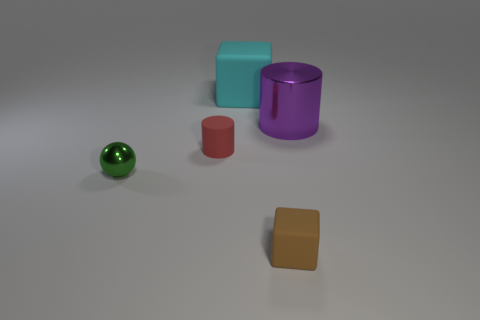What is the shape of the tiny green metallic thing?
Provide a short and direct response. Sphere. There is a thing that is in front of the metal thing that is left of the big purple shiny thing; what is its color?
Your answer should be very brief. Brown. The shiny thing that is the same size as the brown block is what color?
Provide a succinct answer. Green. Are any brown matte blocks visible?
Give a very brief answer. Yes. The metal thing that is in front of the purple metal cylinder has what shape?
Offer a very short reply. Sphere. What number of shiny things are both behind the small rubber cylinder and in front of the large shiny cylinder?
Give a very brief answer. 0. What number of other objects are there of the same size as the sphere?
Provide a succinct answer. 2. There is a small object that is in front of the small green sphere; does it have the same shape as the matte thing behind the big purple shiny thing?
Give a very brief answer. Yes. What number of objects are big purple shiny objects or big purple objects to the right of the red object?
Provide a short and direct response. 1. What material is the thing that is both to the right of the big matte cube and behind the metallic ball?
Ensure brevity in your answer.  Metal. 